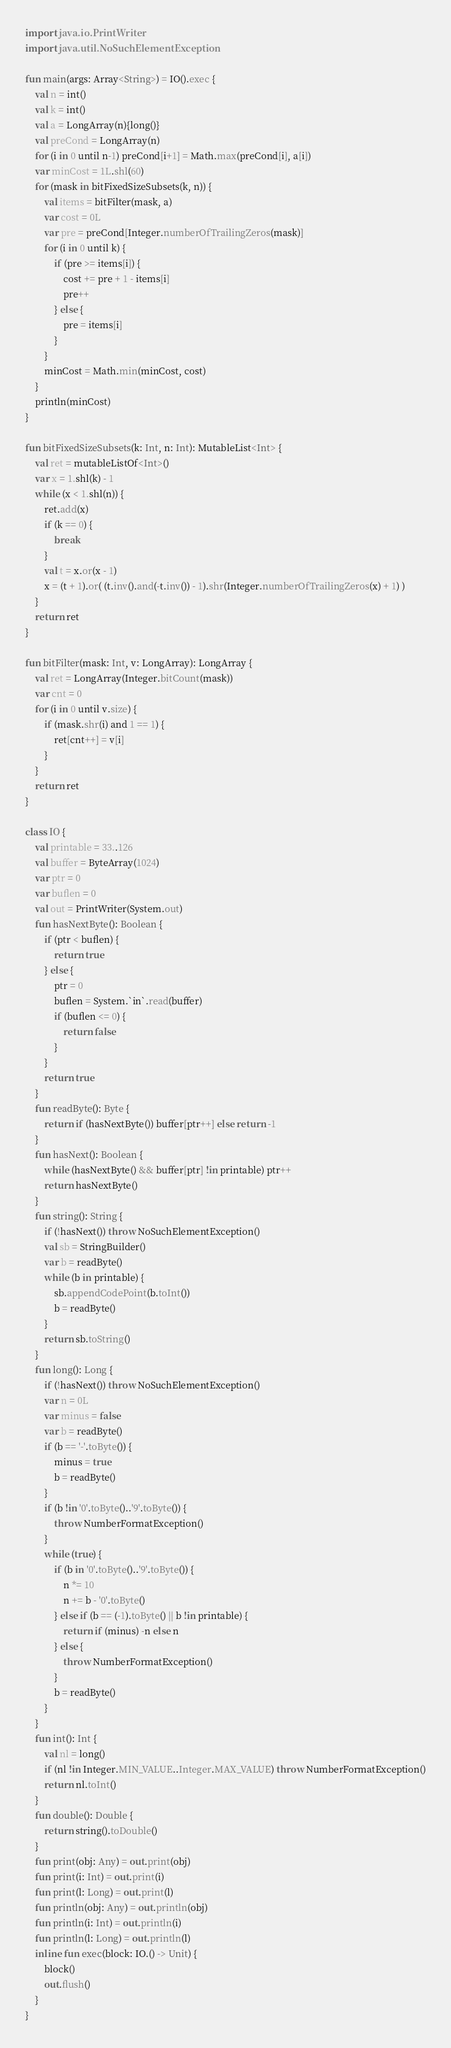<code> <loc_0><loc_0><loc_500><loc_500><_Kotlin_>import java.io.PrintWriter
import java.util.NoSuchElementException

fun main(args: Array<String>) = IO().exec {
    val n = int()
    val k = int()
    val a = LongArray(n){long()}
    val preCond = LongArray(n)
    for (i in 0 until n-1) preCond[i+1] = Math.max(preCond[i], a[i])
    var minCost = 1L.shl(60)
    for (mask in bitFixedSizeSubsets(k, n)) {
        val items = bitFilter(mask, a)
        var cost = 0L
        var pre = preCond[Integer.numberOfTrailingZeros(mask)]
        for (i in 0 until k) {
            if (pre >= items[i]) {
                cost += pre + 1 - items[i]
                pre++
            } else {
                pre = items[i]
            }
        }
        minCost = Math.min(minCost, cost)
    }
    println(minCost)
}

fun bitFixedSizeSubsets(k: Int, n: Int): MutableList<Int> {
    val ret = mutableListOf<Int>()
    var x = 1.shl(k) - 1
    while (x < 1.shl(n)) {
        ret.add(x)
        if (k == 0) {
            break
        }
        val t = x.or(x - 1)
        x = (t + 1).or( (t.inv().and(-t.inv()) - 1).shr(Integer.numberOfTrailingZeros(x) + 1) )
    }
    return ret
}

fun bitFilter(mask: Int, v: LongArray): LongArray {
    val ret = LongArray(Integer.bitCount(mask))
    var cnt = 0
    for (i in 0 until v.size) {
        if (mask.shr(i) and 1 == 1) {
            ret[cnt++] = v[i]
        }
    }
    return ret
}

class IO {
    val printable = 33..126
    val buffer = ByteArray(1024)
    var ptr = 0
    var buflen = 0
    val out = PrintWriter(System.out)
    fun hasNextByte(): Boolean {
        if (ptr < buflen) {
            return true
        } else {
            ptr = 0
            buflen = System.`in`.read(buffer)
            if (buflen <= 0) {
                return false
            }
        }
        return true
    }
    fun readByte(): Byte {
        return if (hasNextByte()) buffer[ptr++] else return -1
    }
    fun hasNext(): Boolean {
        while (hasNextByte() && buffer[ptr] !in printable) ptr++
        return hasNextByte()
    }
    fun string(): String {
        if (!hasNext()) throw NoSuchElementException()
        val sb = StringBuilder()
        var b = readByte()
        while (b in printable) {
            sb.appendCodePoint(b.toInt())
            b = readByte()
        }
        return sb.toString()
    }
    fun long(): Long {
        if (!hasNext()) throw NoSuchElementException()
        var n = 0L
        var minus = false
        var b = readByte()
        if (b == '-'.toByte()) {
            minus = true
            b = readByte()
        }
        if (b !in '0'.toByte()..'9'.toByte()) {
            throw NumberFormatException()
        }
        while (true) {
            if (b in '0'.toByte()..'9'.toByte()) {
                n *= 10
                n += b - '0'.toByte()
            } else if (b == (-1).toByte() || b !in printable) {
                return if (minus) -n else n
            } else {
                throw NumberFormatException()
            }
            b = readByte()
        }
    }
    fun int(): Int {
        val nl = long()
        if (nl !in Integer.MIN_VALUE..Integer.MAX_VALUE) throw NumberFormatException()
        return nl.toInt()
    }
    fun double(): Double {
        return string().toDouble()
    }
    fun print(obj: Any) = out.print(obj)
    fun print(i: Int) = out.print(i)
    fun print(l: Long) = out.print(l)
    fun println(obj: Any) = out.println(obj)
    fun println(i: Int) = out.println(i)
    fun println(l: Long) = out.println(l)
    inline fun exec(block: IO.() -> Unit) {
        block()
        out.flush()
    }
}</code> 